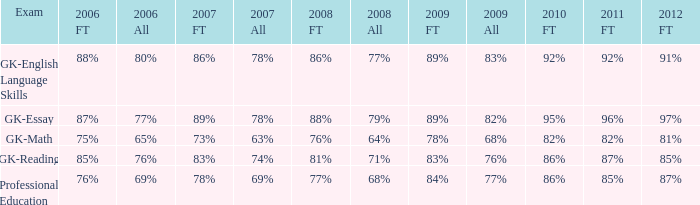What is the percentage for all 2008 when all in 2007 is 69%? 68%. 